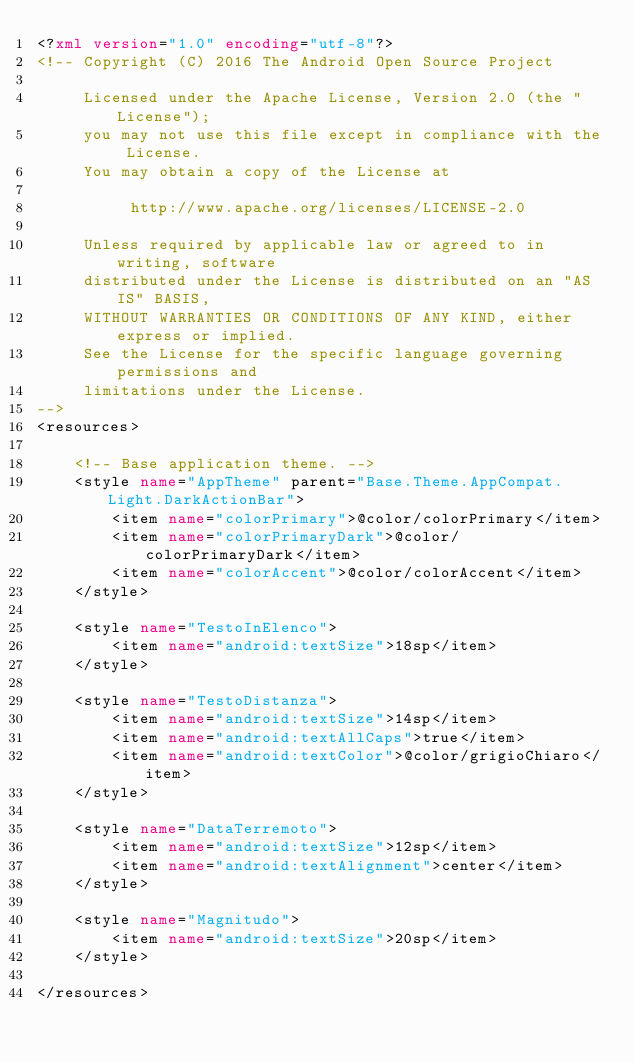Convert code to text. <code><loc_0><loc_0><loc_500><loc_500><_XML_><?xml version="1.0" encoding="utf-8"?>
<!-- Copyright (C) 2016 The Android Open Source Project

     Licensed under the Apache License, Version 2.0 (the "License");
     you may not use this file except in compliance with the License.
     You may obtain a copy of the License at

          http://www.apache.org/licenses/LICENSE-2.0

     Unless required by applicable law or agreed to in writing, software
     distributed under the License is distributed on an "AS IS" BASIS,
     WITHOUT WARRANTIES OR CONDITIONS OF ANY KIND, either express or implied.
     See the License for the specific language governing permissions and
     limitations under the License.
-->
<resources>

    <!-- Base application theme. -->
    <style name="AppTheme" parent="Base.Theme.AppCompat.Light.DarkActionBar">
        <item name="colorPrimary">@color/colorPrimary</item>
        <item name="colorPrimaryDark">@color/colorPrimaryDark</item>
        <item name="colorAccent">@color/colorAccent</item>
    </style>

    <style name="TestoInElenco">
        <item name="android:textSize">18sp</item>
    </style>

    <style name="TestoDistanza">
        <item name="android:textSize">14sp</item>
        <item name="android:textAllCaps">true</item>
        <item name="android:textColor">@color/grigioChiaro</item>
    </style>

    <style name="DataTerremoto">
        <item name="android:textSize">12sp</item>
        <item name="android:textAlignment">center</item>
    </style>

    <style name="Magnitudo">
        <item name="android:textSize">20sp</item>
    </style>

</resources>
</code> 